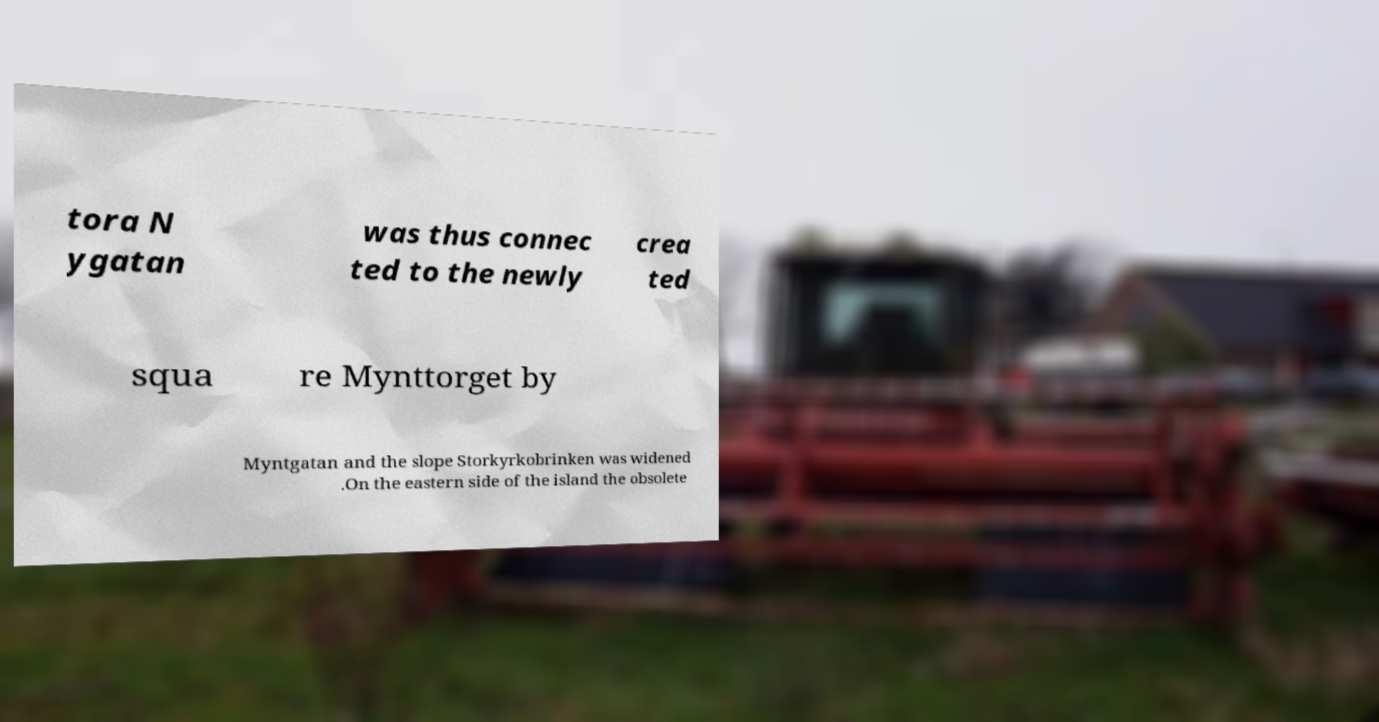Can you read and provide the text displayed in the image?This photo seems to have some interesting text. Can you extract and type it out for me? tora N ygatan was thus connec ted to the newly crea ted squa re Mynttorget by Myntgatan and the slope Storkyrkobrinken was widened .On the eastern side of the island the obsolete 